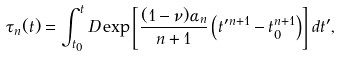Convert formula to latex. <formula><loc_0><loc_0><loc_500><loc_500>\tau _ { n } ( t ) = \int _ { t _ { 0 } } ^ { t } D \exp \left [ \frac { ( 1 - \nu ) \alpha _ { n } } { n + 1 } \left ( t ^ { \prime n + 1 } - t _ { 0 } ^ { n + 1 } \right ) \right ] d t ^ { \prime } ,</formula> 